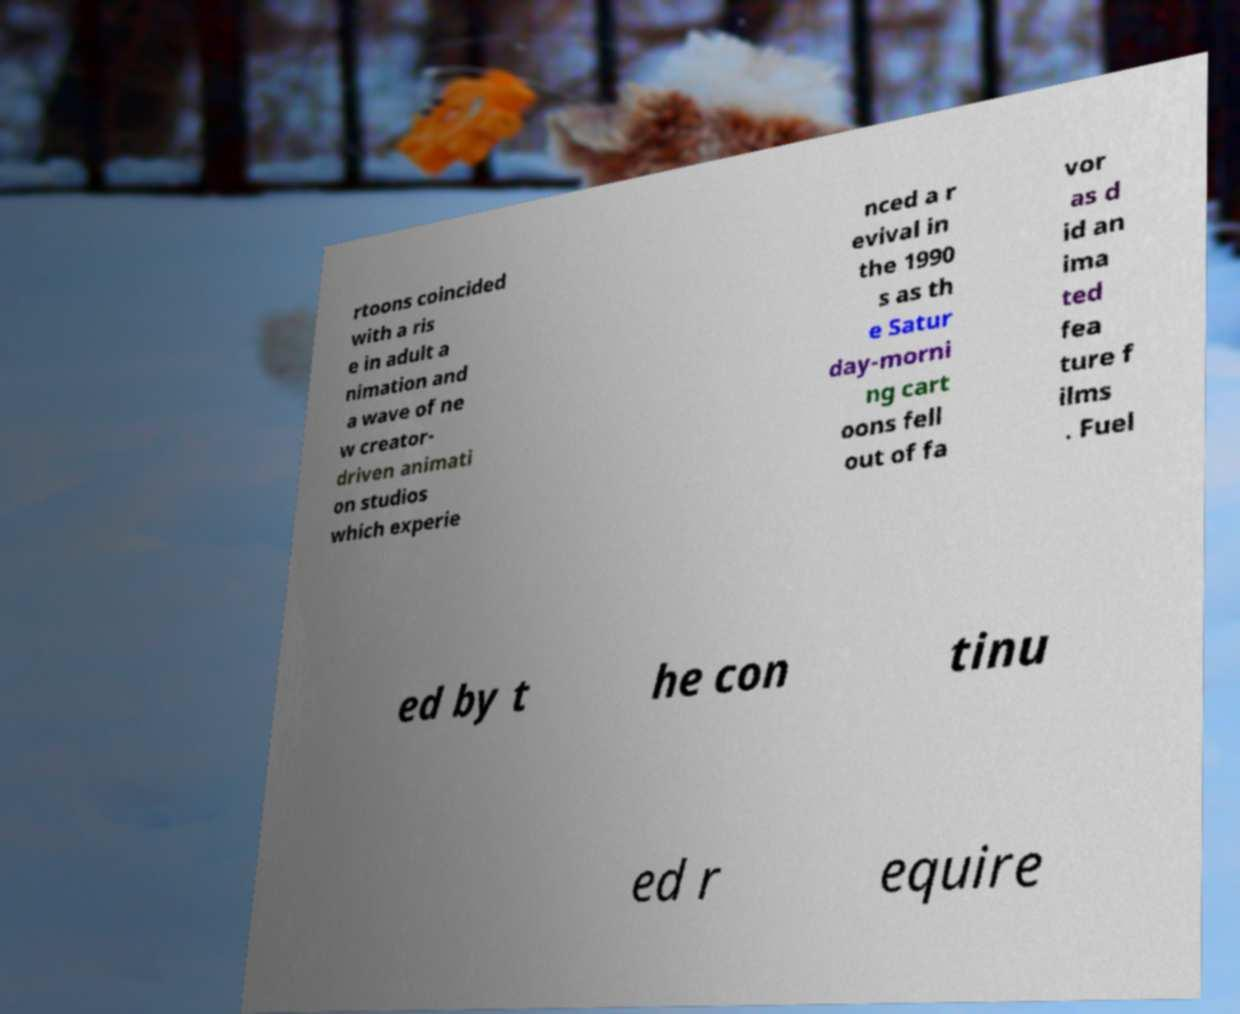Can you accurately transcribe the text from the provided image for me? rtoons coincided with a ris e in adult a nimation and a wave of ne w creator- driven animati on studios which experie nced a r evival in the 1990 s as th e Satur day-morni ng cart oons fell out of fa vor as d id an ima ted fea ture f ilms . Fuel ed by t he con tinu ed r equire 